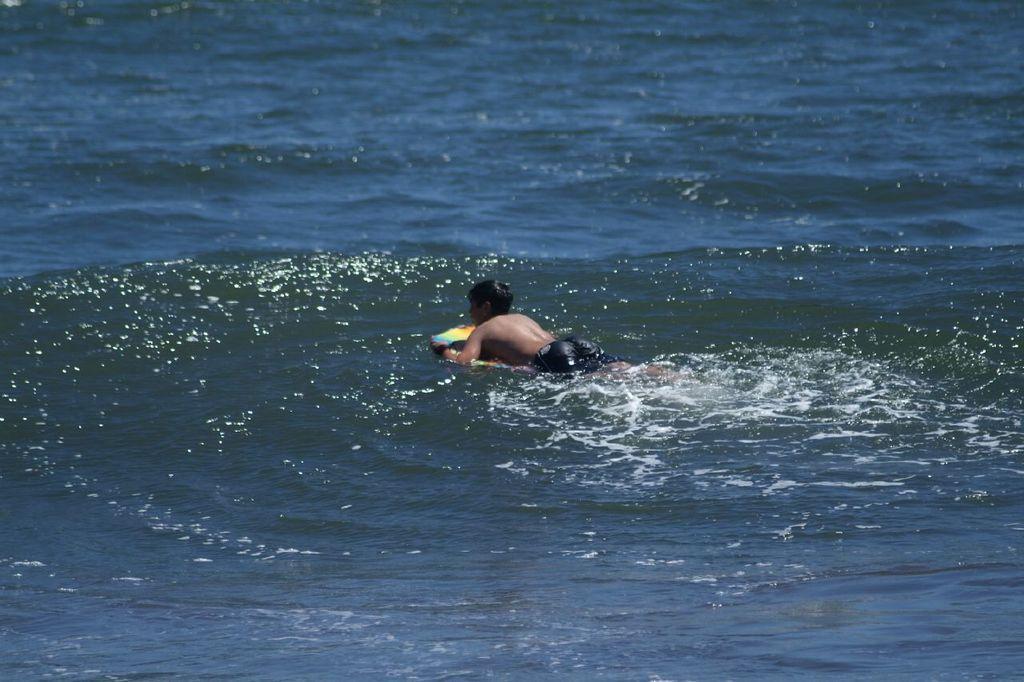Could you give a brief overview of what you see in this image? In this picture there is a boy who is swimming in the water. 